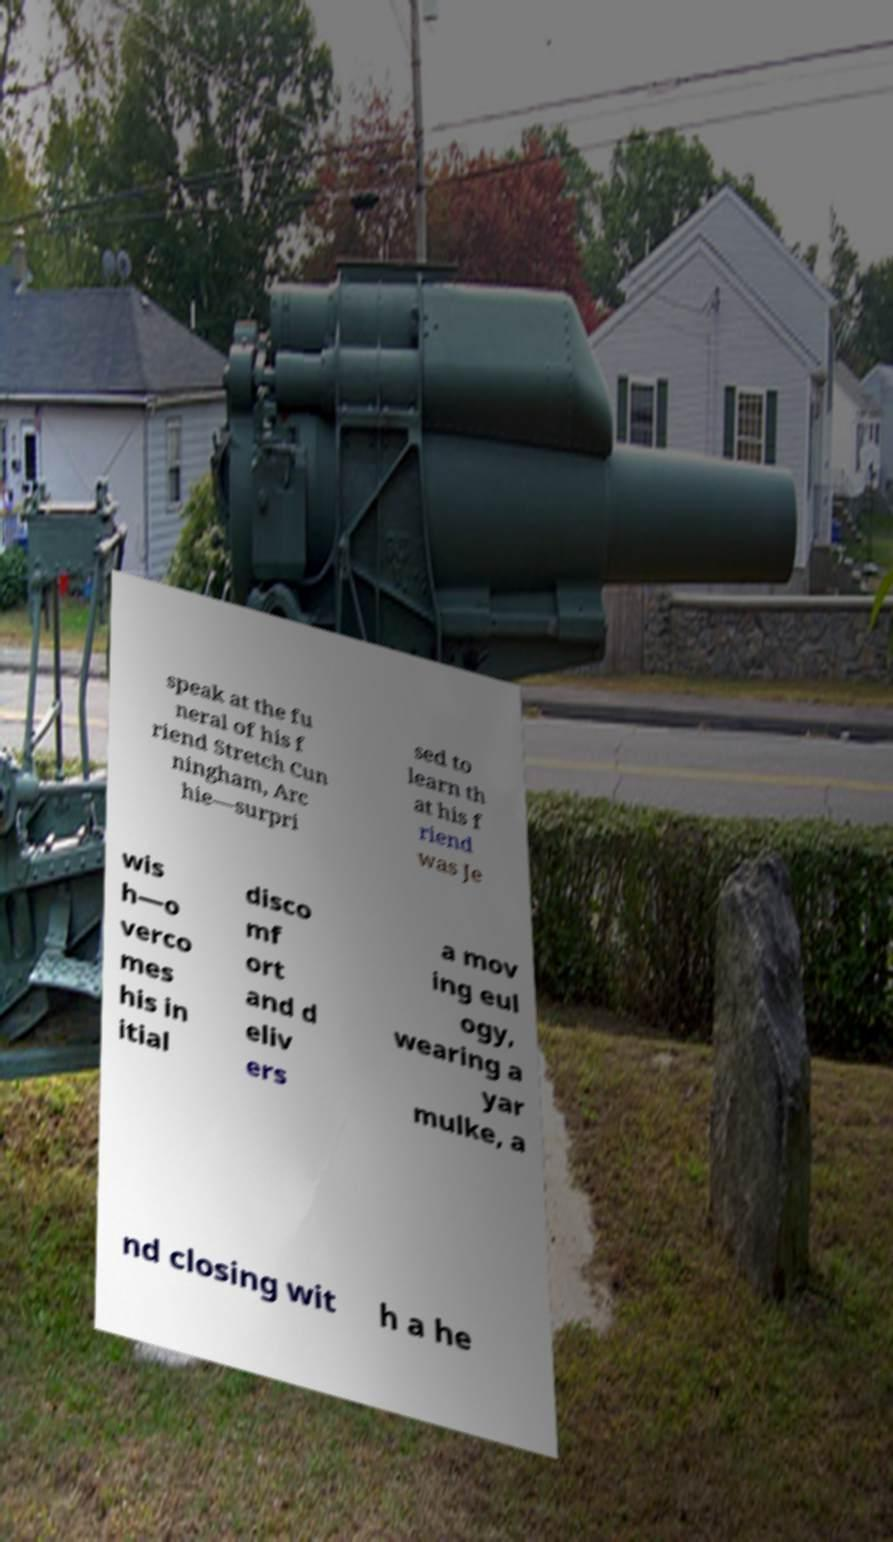I need the written content from this picture converted into text. Can you do that? speak at the fu neral of his f riend Stretch Cun ningham, Arc hie—surpri sed to learn th at his f riend was Je wis h—o verco mes his in itial disco mf ort and d eliv ers a mov ing eul ogy, wearing a yar mulke, a nd closing wit h a he 